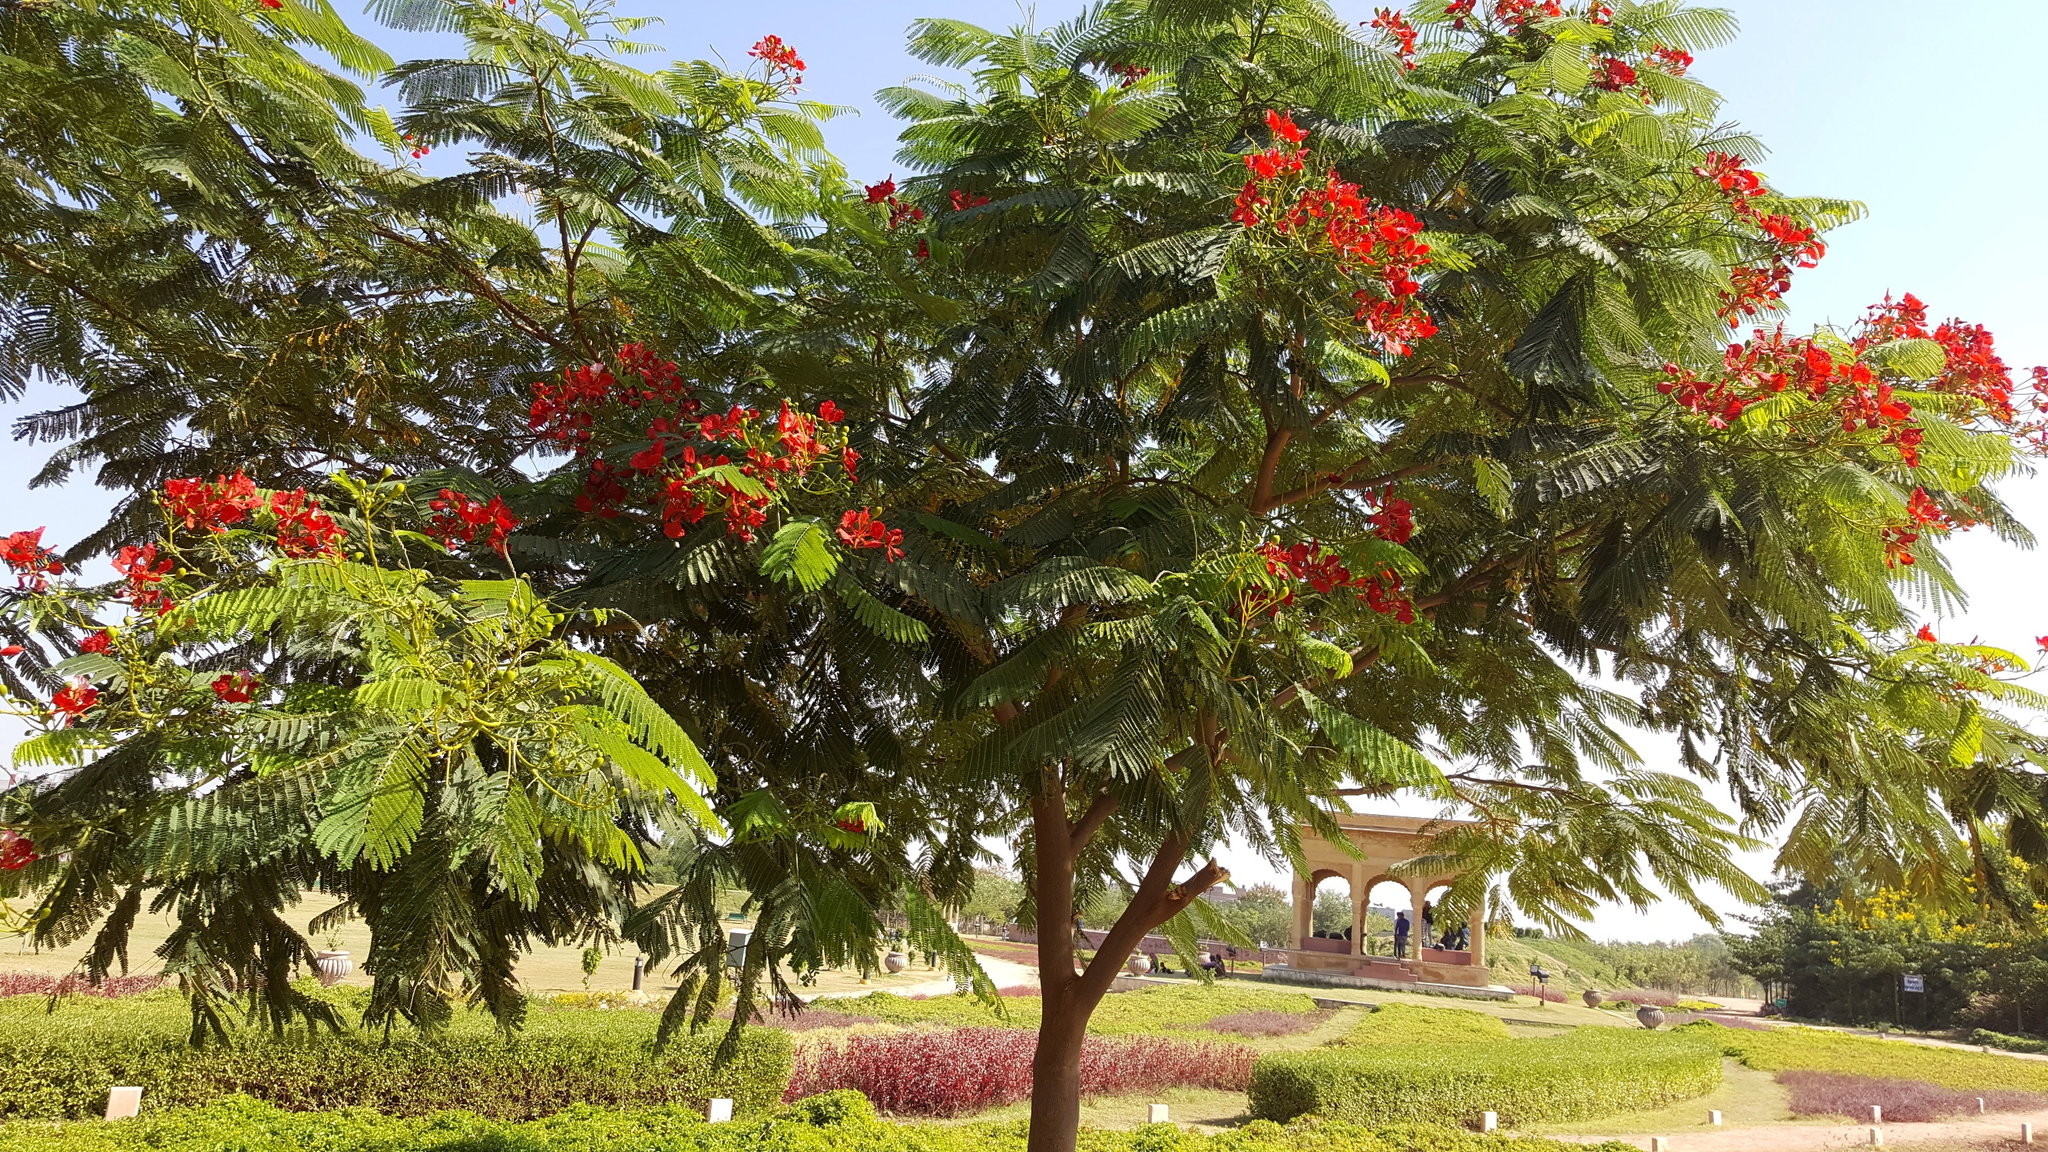What might be the function of the gazebo in the background? The gazebo in the background likely serves multiple functions within the park setting. Architecturally, gazebos are designed to provide shelter and shade while remaining open to the outdoor environment, making them ideal spots for relaxation or protection from the sun and light rain. This gazebo, with its elevated base and open sides, could also be used for small public events such as musical performances, reading sessions, or as an observation point to enjoy the view of the park. 